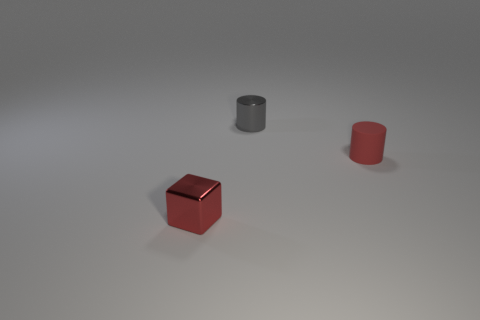There is a shiny object that is behind the small cylinder in front of the tiny shiny cylinder that is behind the red rubber cylinder; what is its shape?
Your answer should be compact. Cylinder. Do the red object on the left side of the gray metallic object and the tiny gray metallic cylinder have the same size?
Make the answer very short. Yes. There is a thing that is in front of the gray shiny cylinder and on the left side of the tiny rubber cylinder; what is its shape?
Your answer should be compact. Cube. Does the tiny metallic cylinder have the same color as the small object in front of the rubber cylinder?
Offer a very short reply. No. There is a small cylinder that is on the right side of the metal object that is behind the tiny red thing in front of the red rubber object; what color is it?
Your answer should be compact. Red. There is another object that is the same shape as the gray thing; what color is it?
Make the answer very short. Red. Are there an equal number of shiny cubes behind the small red cylinder and metal things?
Offer a very short reply. No. What number of cylinders are either matte objects or small red shiny objects?
Ensure brevity in your answer.  1. There is a object that is the same material as the cube; what color is it?
Offer a terse response. Gray. Is the material of the red cylinder the same as the tiny red thing to the left of the tiny gray shiny cylinder?
Your answer should be very brief. No. 